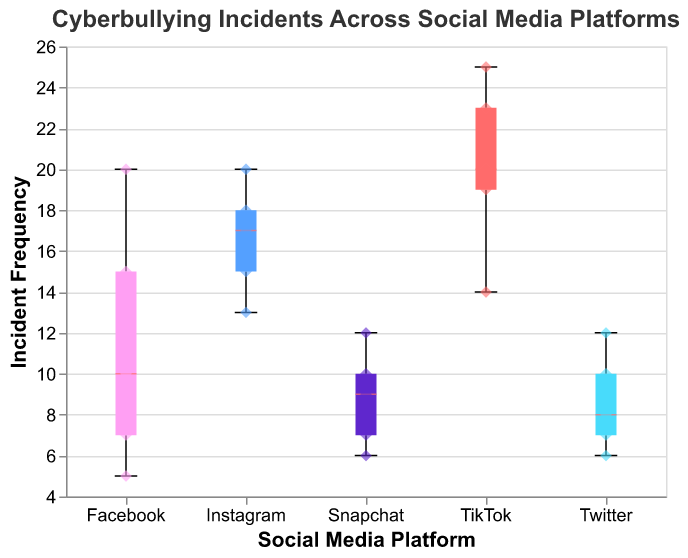What's the median frequency of incidents on Instagram? The box plot shows the median line within the box for each platform. For Instagram, this line corresponds to the value of 15.
Answer: 15 Which platform has the highest maximum frequency of cyberbullying incidents? The highest maximum value is indicated by the top "whisker" of each box plot. TikTok shows the highest maximum frequency with a top whisker at the value of 25.
Answer: TikTok How many data points are included for the Snapchat platform? Each scatter point represents a data point. Counting the scatter points for Snapchat, there are 5 total data points.
Answer: 5 What's the interquartile range (IQR) for Facebook? The IQR is the difference between the third quartile (Q3) and the first quartile (Q1). The top and bottom of the boxes represent Q3 and Q1. For Facebook, Q3 is at 15 and Q1 is at approximately 7, so the IQR is 15 - 7 = 8.
Answer: 8 Which platform shows the widest range of frequencies and what is this range? The range is the difference between the maximum and the minimum values. TikTok has the widest range with a minimum at 14 and a maximum at 25, resulting in a range of 25 - 14 = 11.
Answer: 11 How does the median frequency of Twitter compare to that of Facebook? The box plot shows the median line within the box for each platform. Twitter has a median frequency of 8, while Facebook's median frequency is 10. Facebook's median is thus higher by 2.
Answer: Facebook's median is 2 units higher What is the most frequently occurring severity level for Instagram? By referring to the scatter points with their sizes, the most frequent severity level is 3, with multiple points showing this value.
Answer: 3 Do any platforms have overlapping frequency ranges? By looking at the box plots and their whiskers, Facebook and Snapchat have overlapping frequency ranges of 5 to 20 and 6 to 12, respectively.
Answer: Yes, Facebook and Snapchat What is the range of frequency for Twitter? The range is the difference between the maximum and minimum values. For Twitter, the maximum frequency is 12 and the minimum frequency is 6, resulting in a range of 12 - 6 = 6.
Answer: 6 